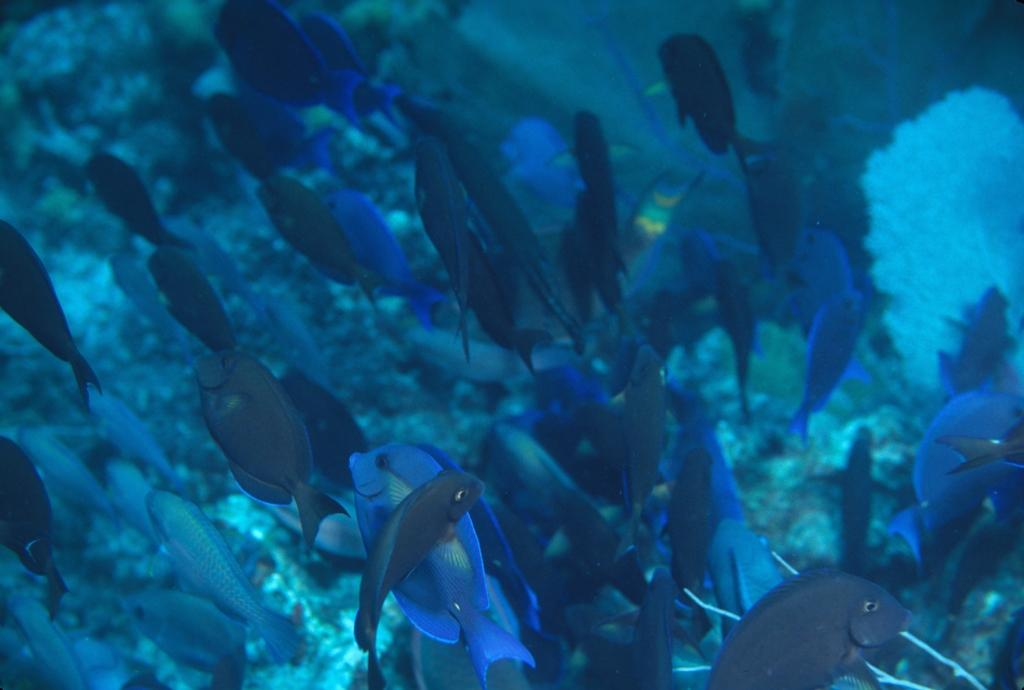What is the primary element visible in the image? There is water in the image. What can be found swimming in the water? There are fishes in the water in the water. What type of oven can be seen in the image? There is no oven present in the image; it features water with fishes. Can you tell me how many members are on the team in the image? There is no team present in the image; it only shows water and fishes. 